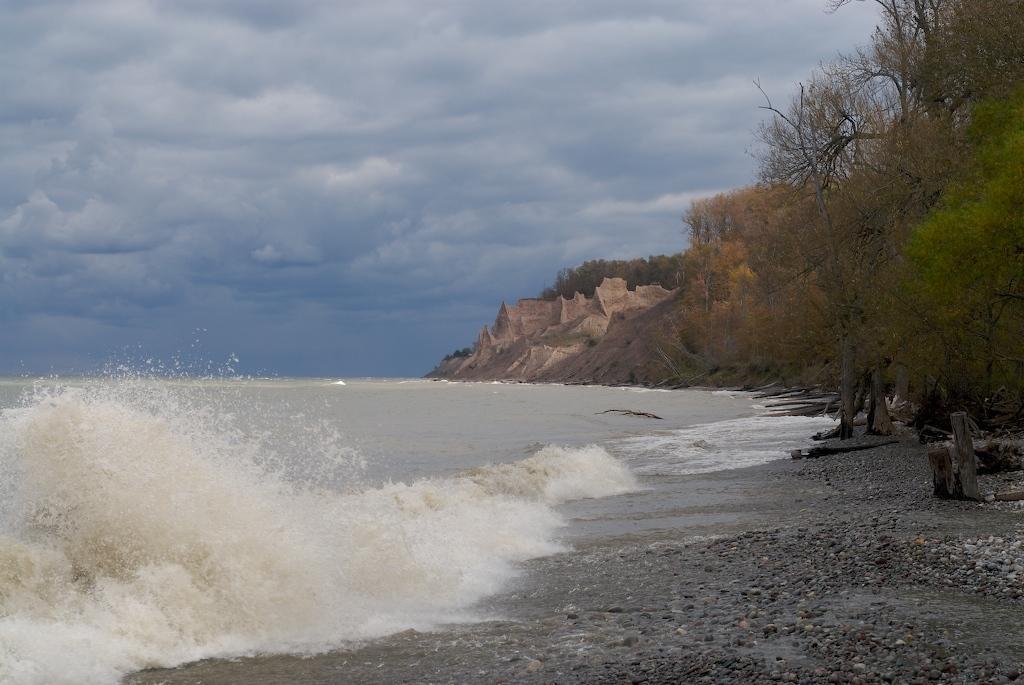How would you summarize this image in a sentence or two? In this image I can see on the left side there is the sea, on the right side there are trees. At the top it is the cloudy sky. 